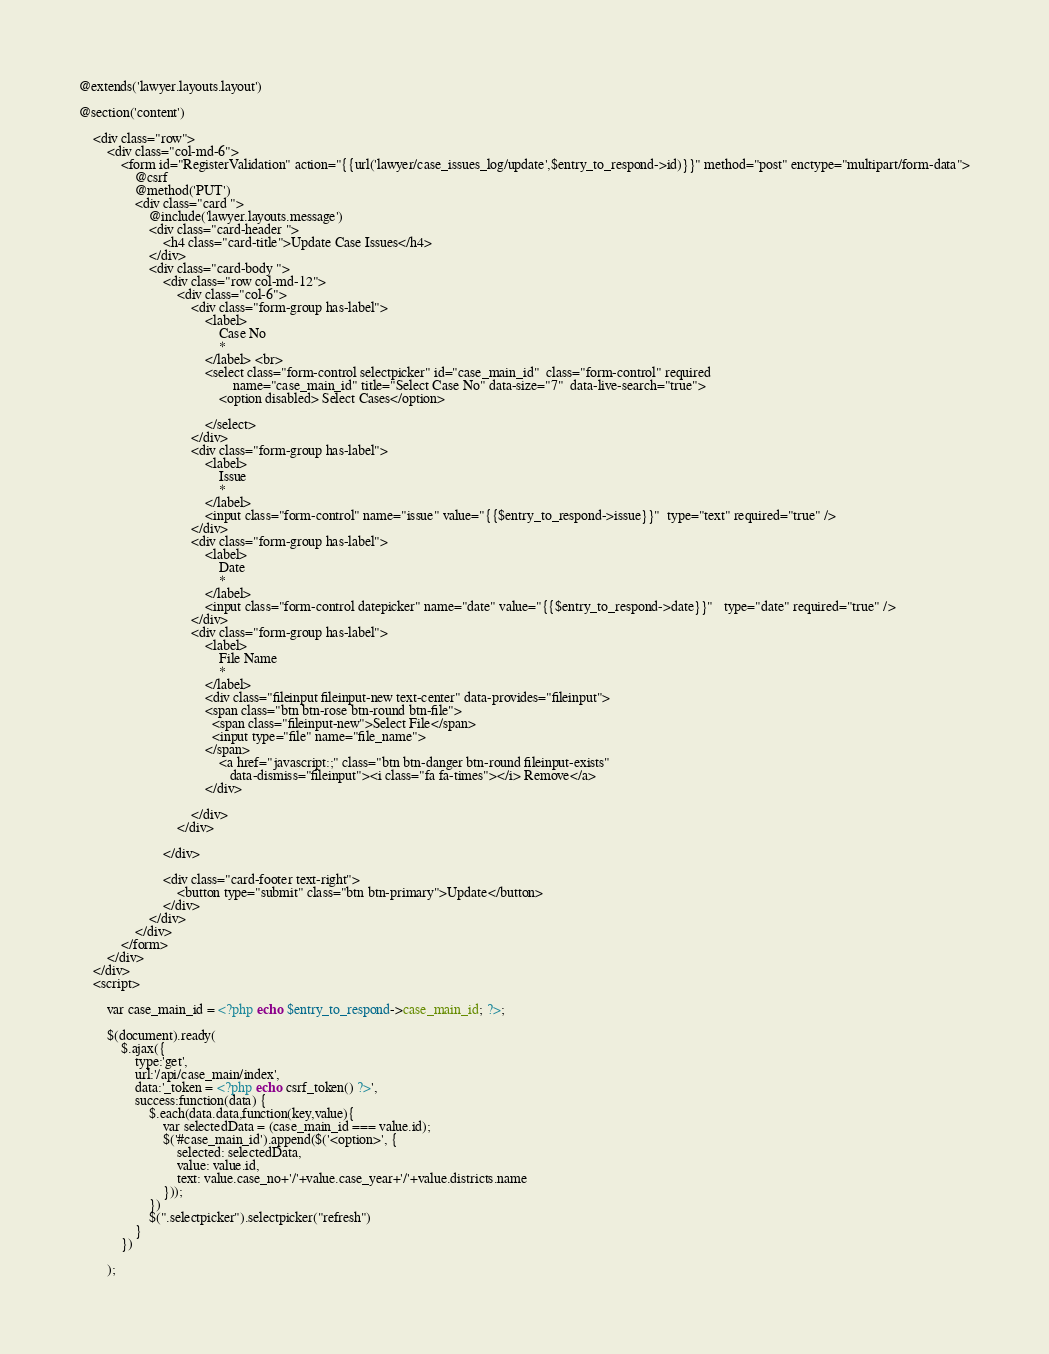Convert code to text. <code><loc_0><loc_0><loc_500><loc_500><_PHP_>@extends('lawyer.layouts.layout')

@section('content')

    <div class="row">
        <div class="col-md-6">
            <form id="RegisterValidation" action="{{url('lawyer/case_issues_log/update',$entry_to_respond->id)}}" method="post" enctype="multipart/form-data">
                @csrf
                @method('PUT')
                <div class="card ">
                    @include('lawyer.layouts.message')
                    <div class="card-header ">
                        <h4 class="card-title">Update Case Issues</h4>
                    </div>
                    <div class="card-body ">
                        <div class="row col-md-12">
                            <div class="col-6">
                                <div class="form-group has-label">
                                    <label>
                                        Case No
                                        *
                                    </label> <br>
                                    <select class="form-control selectpicker" id="case_main_id"  class="form-control" required
                                            name="case_main_id" title="Select Case No" data-size="7"  data-live-search="true">
                                        <option disabled> Select Cases</option>

                                    </select>
                                </div>
                                <div class="form-group has-label">
                                    <label>
                                        Issue
                                        *
                                    </label>
                                    <input class="form-control" name="issue" value="{{$entry_to_respond->issue}}"  type="text" required="true" />
                                </div>
                                <div class="form-group has-label">
                                    <label>
                                        Date
                                        *
                                    </label>
                                    <input class="form-control datepicker" name="date" value="{{$entry_to_respond->date}}"   type="date" required="true" />
                                </div>
                                <div class="form-group has-label">
                                    <label>
                                        File Name
                                        *
                                    </label>
                                    <div class="fileinput fileinput-new text-center" data-provides="fileinput">
                                    <span class="btn btn-rose btn-round btn-file">
                                      <span class="fileinput-new">Select File</span>
                                      <input type="file" name="file_name">
                                    </span>
                                        <a href="javascript:;" class="btn btn-danger btn-round fileinput-exists"
                                           data-dismiss="fileinput"><i class="fa fa-times"></i> Remove</a>
                                    </div>

                                </div>
                            </div>

                        </div>

                        <div class="card-footer text-right">
                            <button type="submit" class="btn btn-primary">Update</button>
                        </div>
                    </div>
                </div>
            </form>
        </div>
    </div>
    <script>

        var case_main_id = <?php echo $entry_to_respond->case_main_id; ?>;

        $(document).ready(
            $.ajax({
                type:'get',
                url:'/api/case_main/index',
                data:'_token = <?php echo csrf_token() ?>',
                success:function(data) {
                    $.each(data.data,function(key,value){
                        var selectedData = (case_main_id === value.id);
                        $('#case_main_id').append($('<option>', {
                            selected: selectedData,
                            value: value.id,
                            text: value.case_no+'/'+value.case_year+'/'+value.districts.name
                        }));
                    })
                    $(".selectpicker").selectpicker("refresh")
                }
            })

        );</code> 